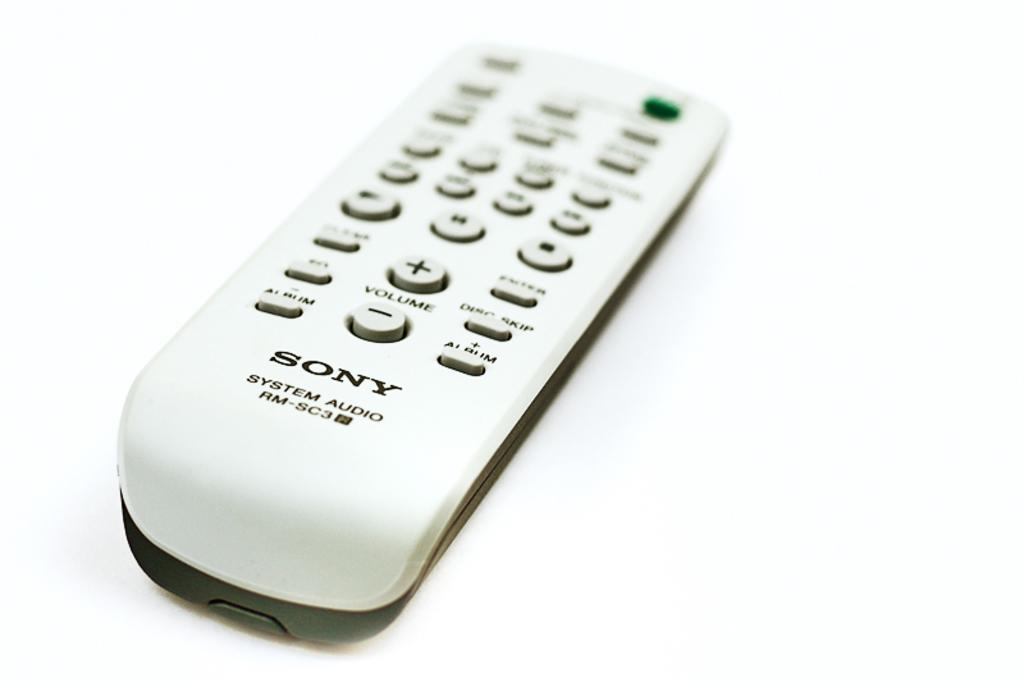What object is visible in the image? There is a remote in the image. Where is the remote located? The remote is placed on a surface. How many sisters are depicted holding berries in the image? There are no sisters or berries present in the image; it only features a remote placed on a surface. 